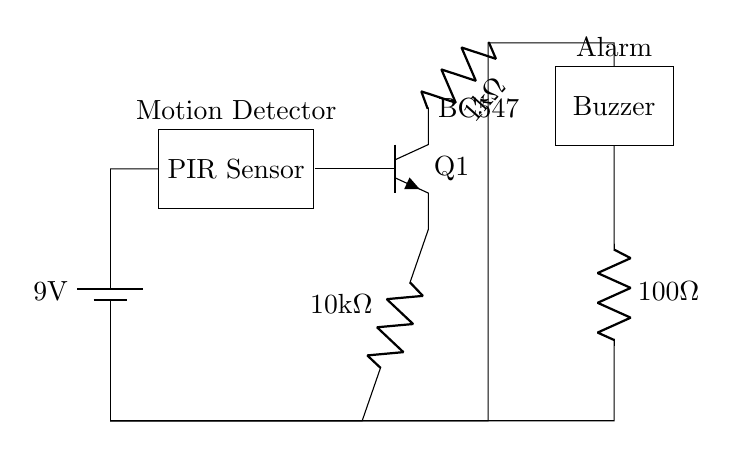What is the power supply voltage for this circuit? The circuit is powered by a battery labeled as 9 volts, which indicates the potential difference supplied to the components.
Answer: 9 volts What type of sensor is used in this circuit? The diagram includes a component labeled as a PIR Sensor, which is designed to detect motion based on changes in infrared radiation.
Answer: PIR Sensor What is the resistance value of the resistor connected to the transistor's collector? There is a resistor labeled 1 kilo ohm connected to the collector of the transistor in the circuit.
Answer: 1 kilo ohm Which component acts as the alarm in this circuit? The circuit diagram labels a component as a Buzzer, which produces sound to signal an alarm condition when triggered by the motion sensor.
Answer: Buzzer How is the PIR sensor connected to the transistor? The PIR Sensor is connected to the base terminal of the transistor, indicating that it controls the transistor based on detected motion.
Answer: To the base terminal Explain the function of the transistor (Q1) in this circuit. The transistor labeled Q1 functions as a switch that amplifies the signal from the PIR Sensor; when motion is detected, it allows current to flow from the collector to the emitter, activating the buzzer.
Answer: Acts as a switch 